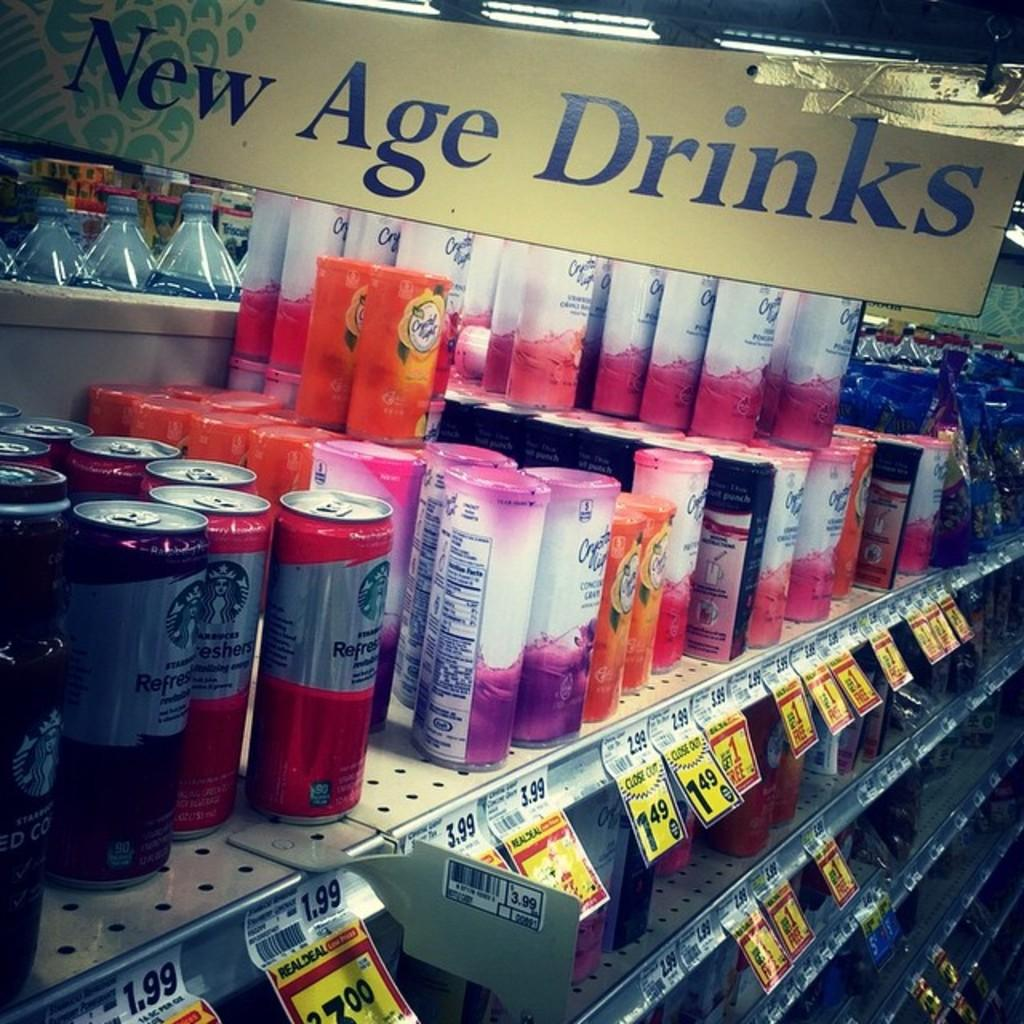Provide a one-sentence caption for the provided image. A store has a display of New Age Drinks for sale. 